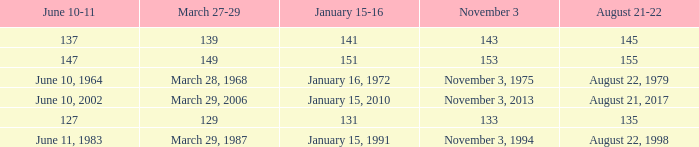What is shown for  august 21-22 when november 3 is november 3, 1994? August 22, 1998. 